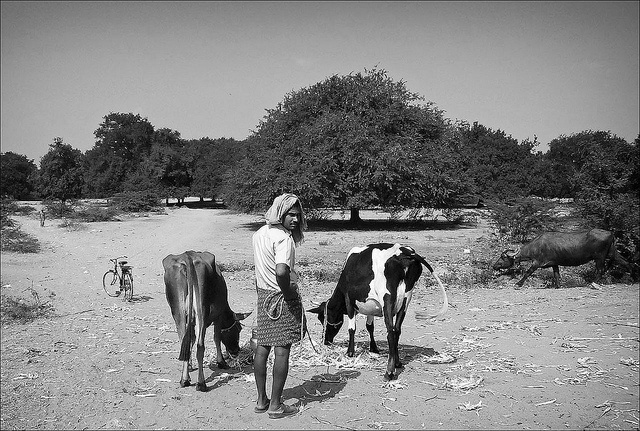Describe the objects in this image and their specific colors. I can see people in black, gray, lightgray, and darkgray tones, cow in black, lightgray, gray, and darkgray tones, cow in black, gray, darkgray, and lightgray tones, cow in black, gray, and lightgray tones, and bicycle in black, lightgray, darkgray, and gray tones in this image. 